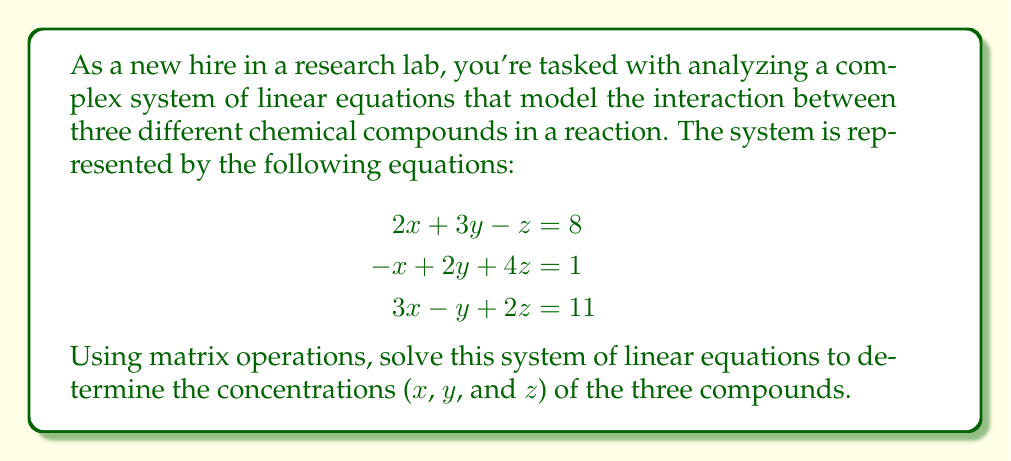What is the answer to this math problem? To solve this system using matrix operations, we'll follow these steps:

1) First, we'll express the system in matrix form AX = B:

   $$\begin{bmatrix}
   2 & 3 & -1 \\
   -1 & 2 & 4 \\
   3 & -1 & 2
   \end{bmatrix}
   \begin{bmatrix}
   x \\
   y \\
   z
   \end{bmatrix} =
   \begin{bmatrix}
   8 \\
   1 \\
   11
   \end{bmatrix}$$

2) To solve for X, we need to find $A^{-1}$ and then compute $X = A^{-1}B$. Let's find $A^{-1}$ using the adjugate method:

   $A^{-1} = \frac{1}{\det(A)} \cdot \text{adj}(A)$

3) Calculate $\det(A)$:
   
   $\det(A) = 2(2\cdot2 - (-1)\cdot4) - 3(-1\cdot2 - 3\cdot4) + (-1)((-1)\cdot(-1) - 3\cdot2)$
   $= 2(4+4) - 3(-2-12) + (-1)(1-6) = 16 + 42 + 5 = 63$

4) Calculate $\text{adj}(A)$:

   $$\text{adj}(A) = \begin{bmatrix}
   7 & -10 & -11 \\
   1 & 8 & -5 \\
   -1 & 7 & 7
   \end{bmatrix}$$

5) Now we can calculate $A^{-1}$:

   $$A^{-1} = \frac{1}{63} \begin{bmatrix}
   7 & -10 & -11 \\
   1 & 8 & -5 \\
   -1 & 7 & 7
   \end{bmatrix}$$

6) Finally, we can solve for X:

   $$X = A^{-1}B = \frac{1}{63} \begin{bmatrix}
   7 & -10 & -11 \\
   1 & 8 & -5 \\
   -1 & 7 & 7
   \end{bmatrix}
   \begin{bmatrix}
   8 \\
   1 \\
   11
   \end{bmatrix}$$

   $$= \frac{1}{63} \begin{bmatrix}
   7(8) + (-10)(1) + (-11)(11) \\
   1(8) + 8(1) + (-5)(11) \\
   (-1)(8) + 7(1) + 7(11)
   \end{bmatrix}
   = \frac{1}{63} \begin{bmatrix}
   56 - 10 - 121 \\
   8 + 8 - 55 \\
   -8 + 7 + 77
   \end{bmatrix}
   = \begin{bmatrix}
   -75/63 \\
   -39/63 \\
   76/63
   \end{bmatrix}$$
Answer: The solution to the system of linear equations is:

$x = -\frac{75}{63} = -1.19$ (rounded to 2 decimal places)
$y = -\frac{39}{63} = -0.62$ (rounded to 2 decimal places)
$z = \frac{76}{63} = 1.21$ (rounded to 2 decimal places)

These values represent the concentrations of the three chemical compounds in the reaction. 